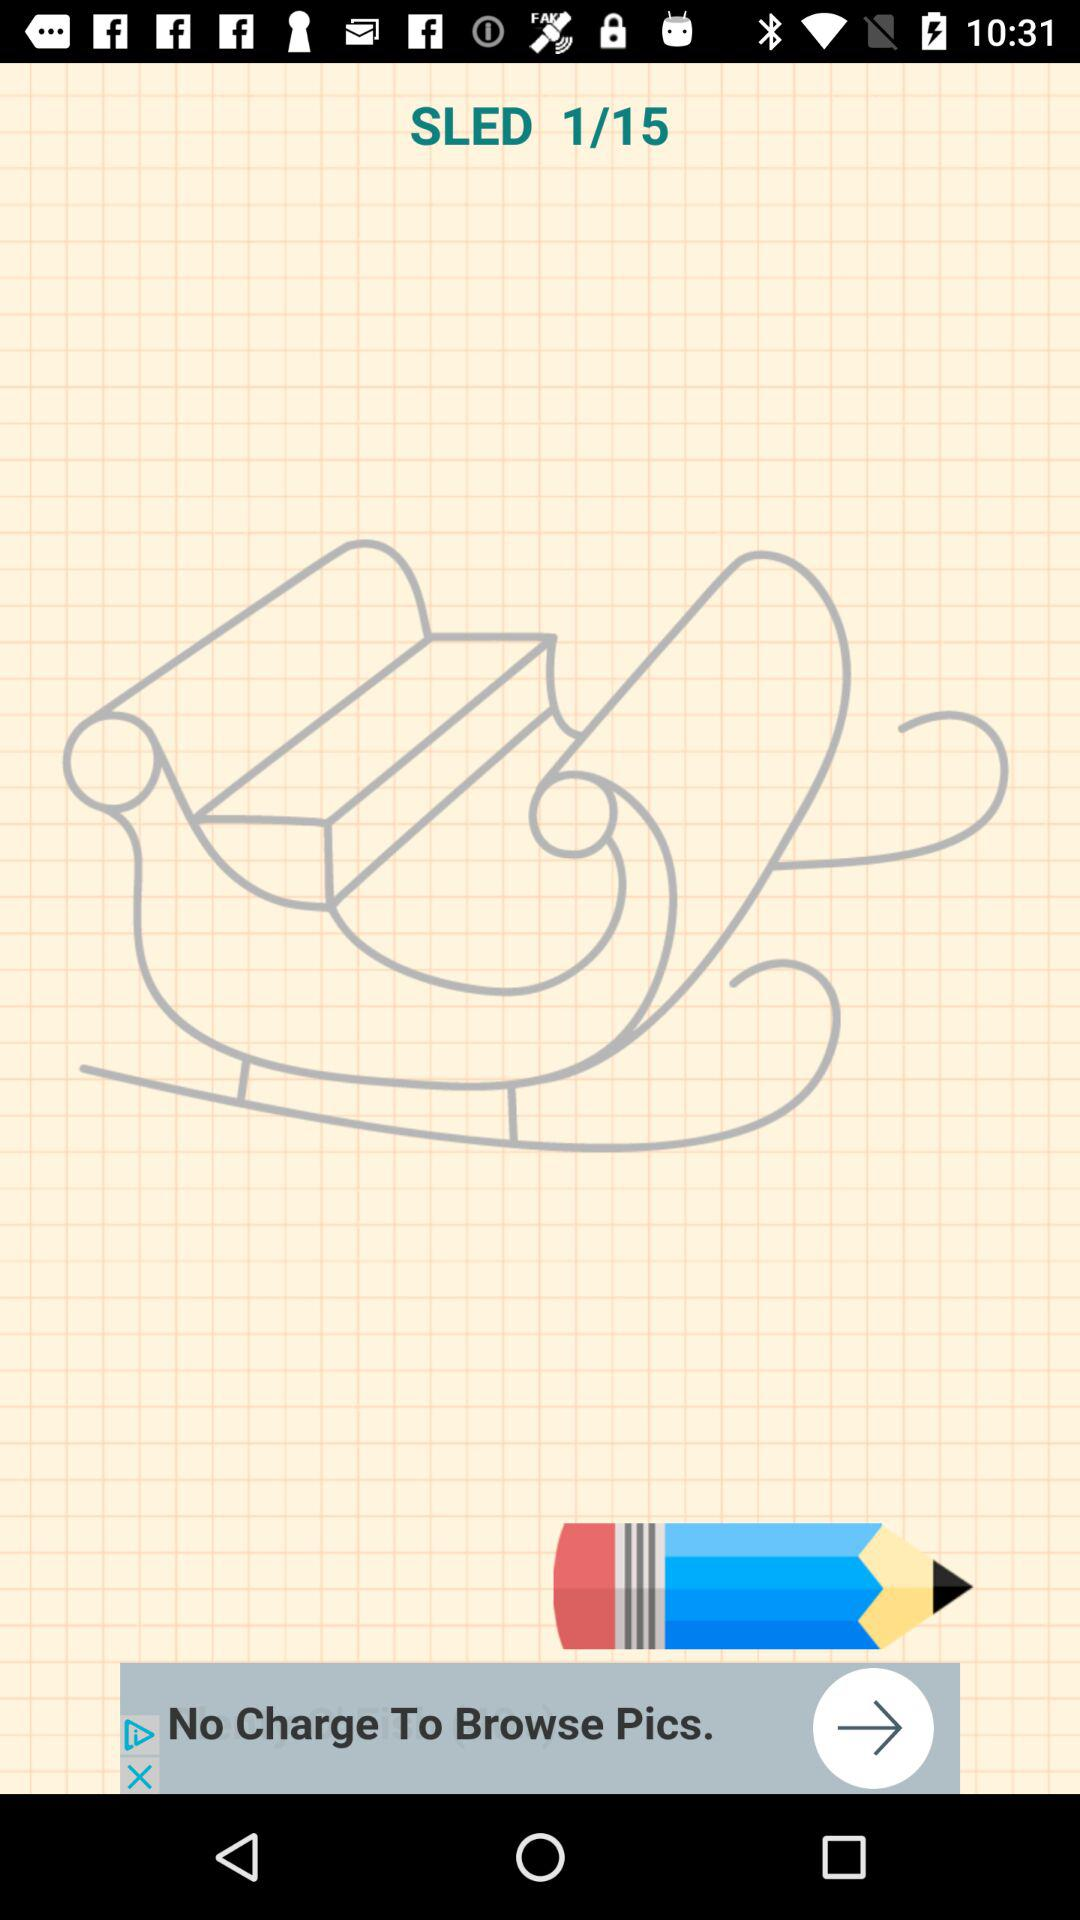Which is the current image number? The current image number is 1. 